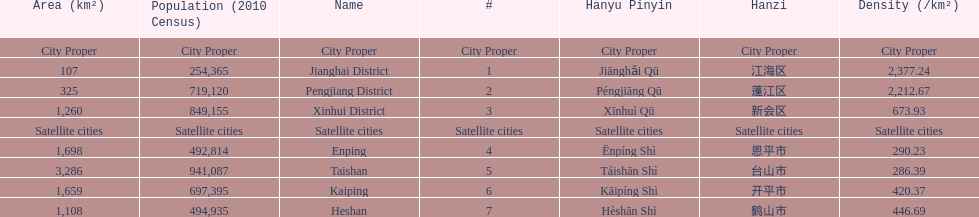Which area has the largest population? Taishan. 